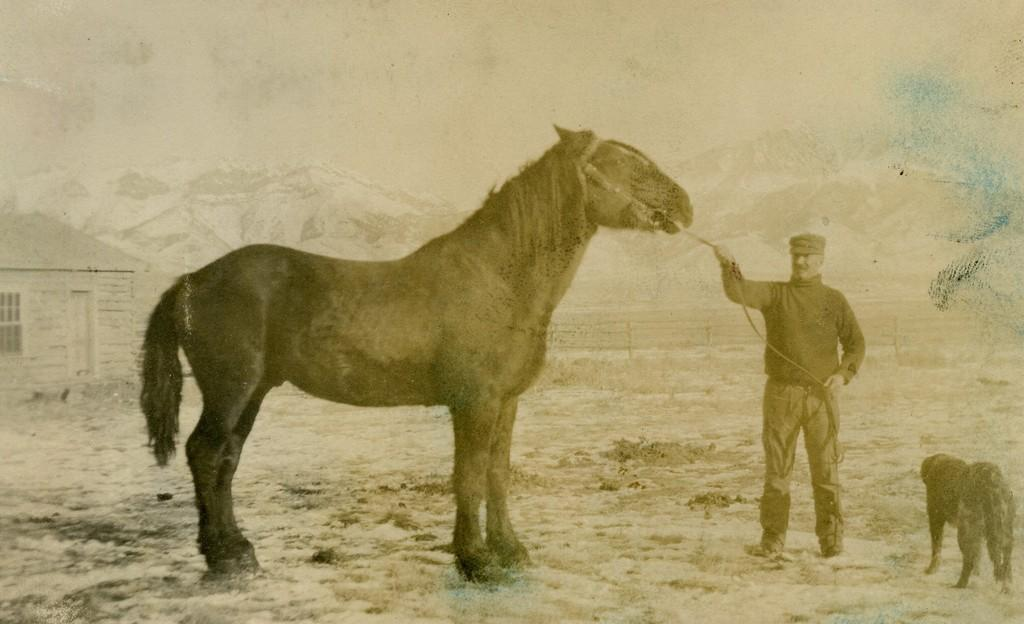What is the main subject of the image? There is a person in the image. What is the person doing in the image? The person is holding a horse. Are there any other animals present in the image? Yes, there is a dog in front of the horse. What type of structure can be seen in the image? There is a house in the image. How many loaves of bread are visible in the image? There are no loaves of bread present in the image. What type of geese can be seen interacting with the dog in the image? There are no geese present in the image; only a person, a horse, and a dog are visible. 